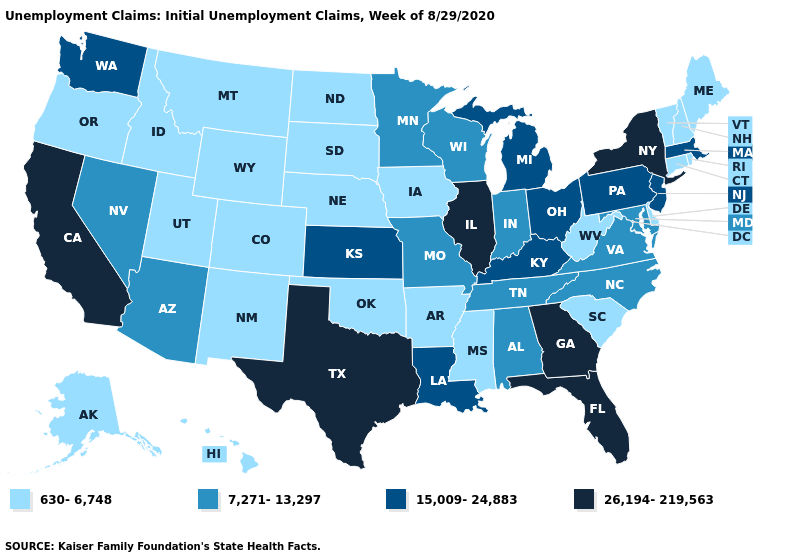Name the states that have a value in the range 15,009-24,883?
Short answer required. Kansas, Kentucky, Louisiana, Massachusetts, Michigan, New Jersey, Ohio, Pennsylvania, Washington. Which states hav the highest value in the Northeast?
Keep it brief. New York. Does New York have the same value as Missouri?
Write a very short answer. No. Name the states that have a value in the range 26,194-219,563?
Short answer required. California, Florida, Georgia, Illinois, New York, Texas. Name the states that have a value in the range 15,009-24,883?
Answer briefly. Kansas, Kentucky, Louisiana, Massachusetts, Michigan, New Jersey, Ohio, Pennsylvania, Washington. Name the states that have a value in the range 26,194-219,563?
Quick response, please. California, Florida, Georgia, Illinois, New York, Texas. Does Kentucky have the lowest value in the South?
Keep it brief. No. Name the states that have a value in the range 15,009-24,883?
Short answer required. Kansas, Kentucky, Louisiana, Massachusetts, Michigan, New Jersey, Ohio, Pennsylvania, Washington. Among the states that border Washington , which have the highest value?
Concise answer only. Idaho, Oregon. Name the states that have a value in the range 15,009-24,883?
Write a very short answer. Kansas, Kentucky, Louisiana, Massachusetts, Michigan, New Jersey, Ohio, Pennsylvania, Washington. Among the states that border Connecticut , does New York have the highest value?
Give a very brief answer. Yes. Does Wyoming have a lower value than Maryland?
Give a very brief answer. Yes. What is the highest value in states that border Colorado?
Quick response, please. 15,009-24,883. Does Hawaii have the lowest value in the USA?
Keep it brief. Yes. 